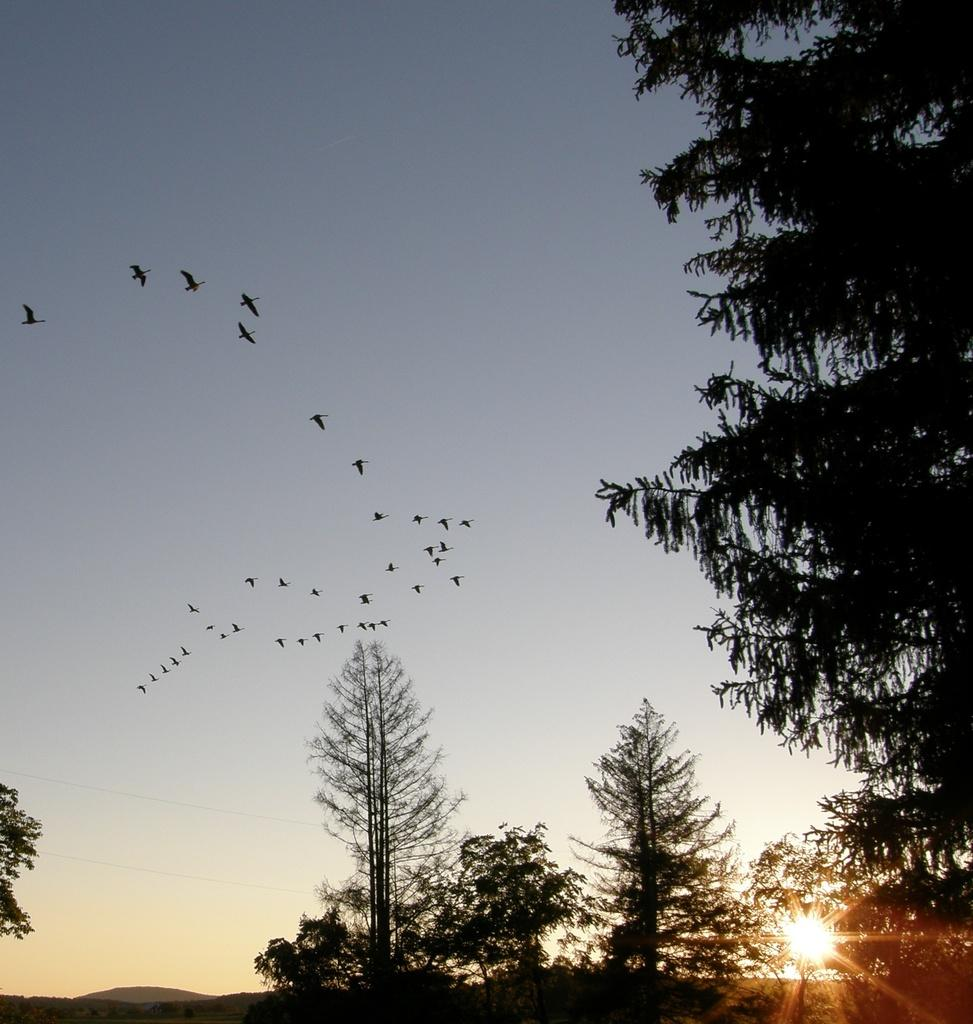What type of vegetation can be seen in the image? There are trees in the image. What animals are present in the image? There are flocks of birds in the image. What part of the natural environment is visible in the image? The sky is visible in the image. What type of stamp can be seen on the monkey's back in the image? There is no monkey present in the image, and therefore no stamp can be seen on its back. 